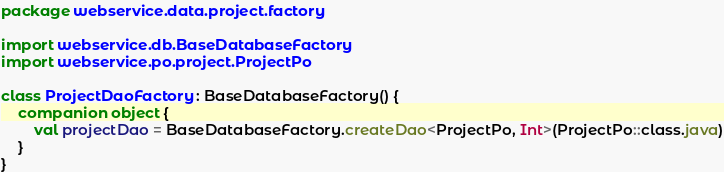<code> <loc_0><loc_0><loc_500><loc_500><_Kotlin_>package webservice.data.project.factory

import webservice.db.BaseDatabaseFactory
import webservice.po.project.ProjectPo

class ProjectDaoFactory : BaseDatabaseFactory() {
    companion object {
        val projectDao = BaseDatabaseFactory.createDao<ProjectPo, Int>(ProjectPo::class.java)
    }
}

</code> 